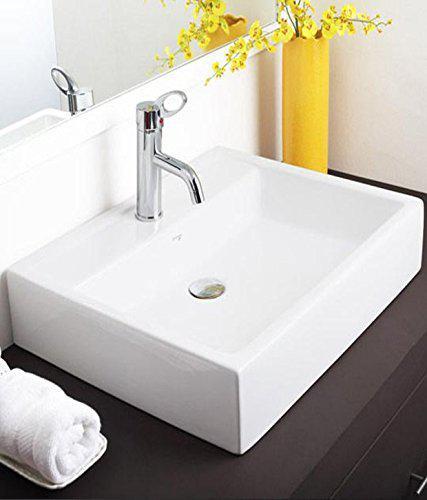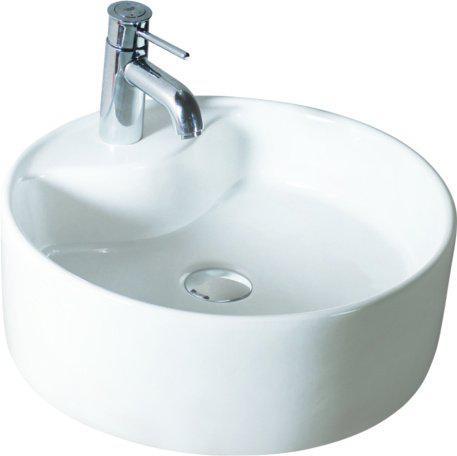The first image is the image on the left, the second image is the image on the right. Examine the images to the left and right. Is the description "One sink has a gooseneck faucet with a turned-down curved spout." accurate? Answer yes or no. No. 